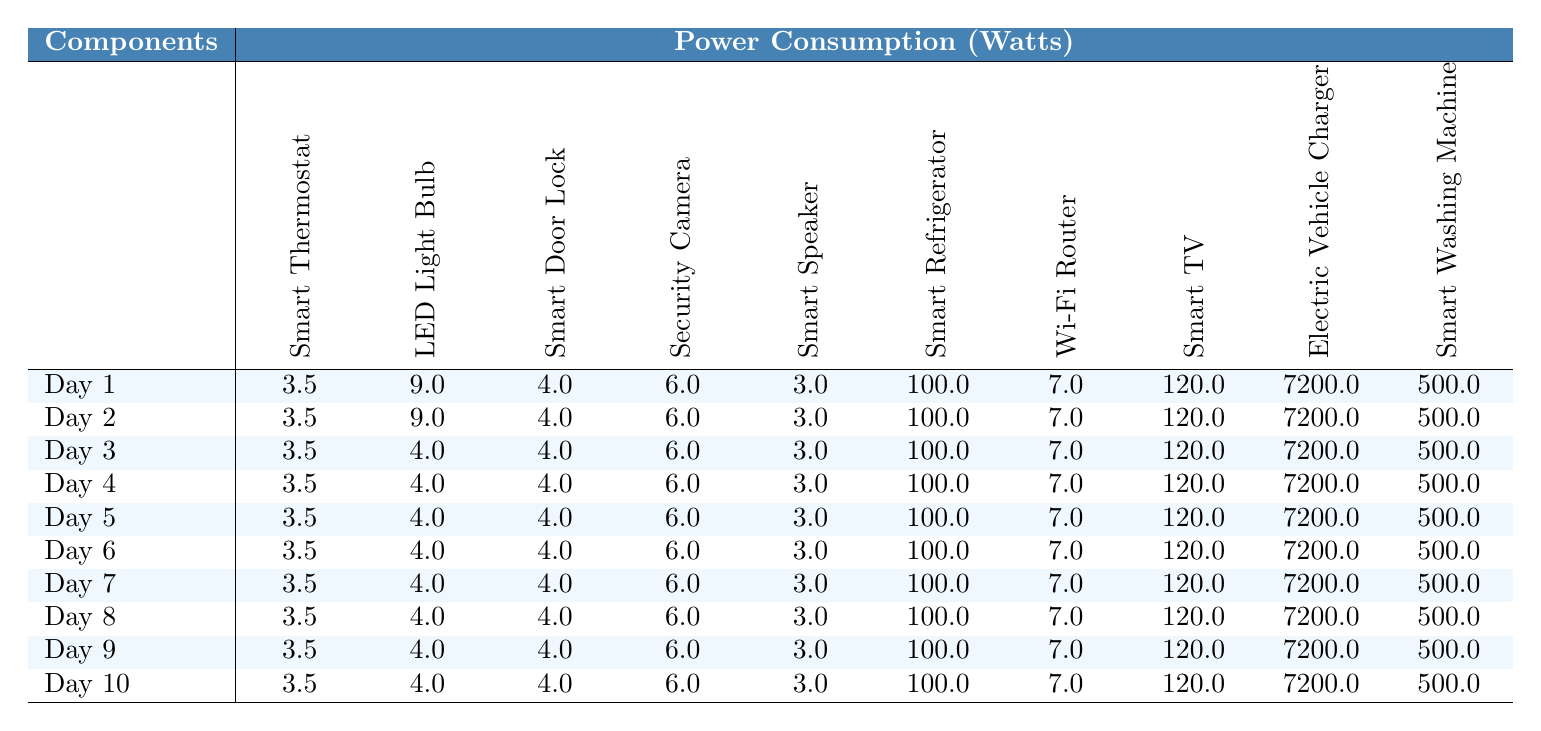What is the power consumption of the Smart Speaker on Day 1? The power consumption of the Smart Speaker on Day 1 is directly shown in the corresponding cell in the row for Day 1. It states 3.0 Watts.
Answer: 3.0 Watts What is the highest power consumption recorded among the components? By scanning the table, the values for power consumption show that the Electric Vehicle Charger has the highest value at 7200.0 Watts.
Answer: 7200.0 Watts Is the power consumption of the Smart Refrigerator consistent across all days? Checking the column for the Smart Refrigerator shows that the power consumption is listed as 100.0 Watts every day, indicating consistency.
Answer: Yes What is the average power consumption of the LED Light Bulb over the ten days? The power consumption of the LED Light Bulb has values of 9.0 Watts for Days 1 and 2 and 4.0 Watts for Days 3 to 10. Summing these yields (9 + 9 + 4*8) = 9 + 9 + 32 = 50. Since there are 10 days, the average is 50 / 10 = 5.0 Watts.
Answer: 5.0 Watts What is the total power consumption of the Security Camera over the first 5 days? The power consumption for the Security Camera is consistently 6.0 Watts for Days 1 to 5. Multiplying by the number of days, 6.0 Watts x 5 days = 30.0 Watts total.
Answer: 30.0 Watts How does the power consumption of the Smart Door Lock compare to the Smart TV on Day 3? On Day 3, the Smart Door Lock consumes 4.0 Watts, while the Smart TV consumes 120.0 Watts. Comparing these values, the Smart TV consumes significantly more.
Answer: Smart TV consumes more What is the difference in power consumption between the Smart Washer and Smart Refrigerator on Day 10? On Day 10, the Smart Washing Machine uses 500.0 Watts and the Smart Refrigerator uses 100.0 Watts. The difference is 500.0 - 100.0 = 400.0 Watts.
Answer: 400.0 Watts On how many days does the Smart Thermostat consume more than 4 Watts? The Smart Thermostat consumes 3.5 Watts every day, which is less than 4 Watts. Therefore, it consumes more than 4 Watts on 0 days.
Answer: 0 days What is the total power consumption of all components combined on Day 1? On Day 1, the power values are summed: 3.5 + 9 + 4 + 6 + 3 + 100 + 7 + 120 + 7200 + 500 = 6342.5 Watts total for all components.
Answer: 6342.5 Watts Is there any day where the total power consumption exceeds 7000 Watts? From examining the rows, only Day 1 adds up to 6342.5 Watts, while every other day does not exceed this value, indicating that Day 1 is the only day but it does not exceed 7000 Watts.
Answer: No 